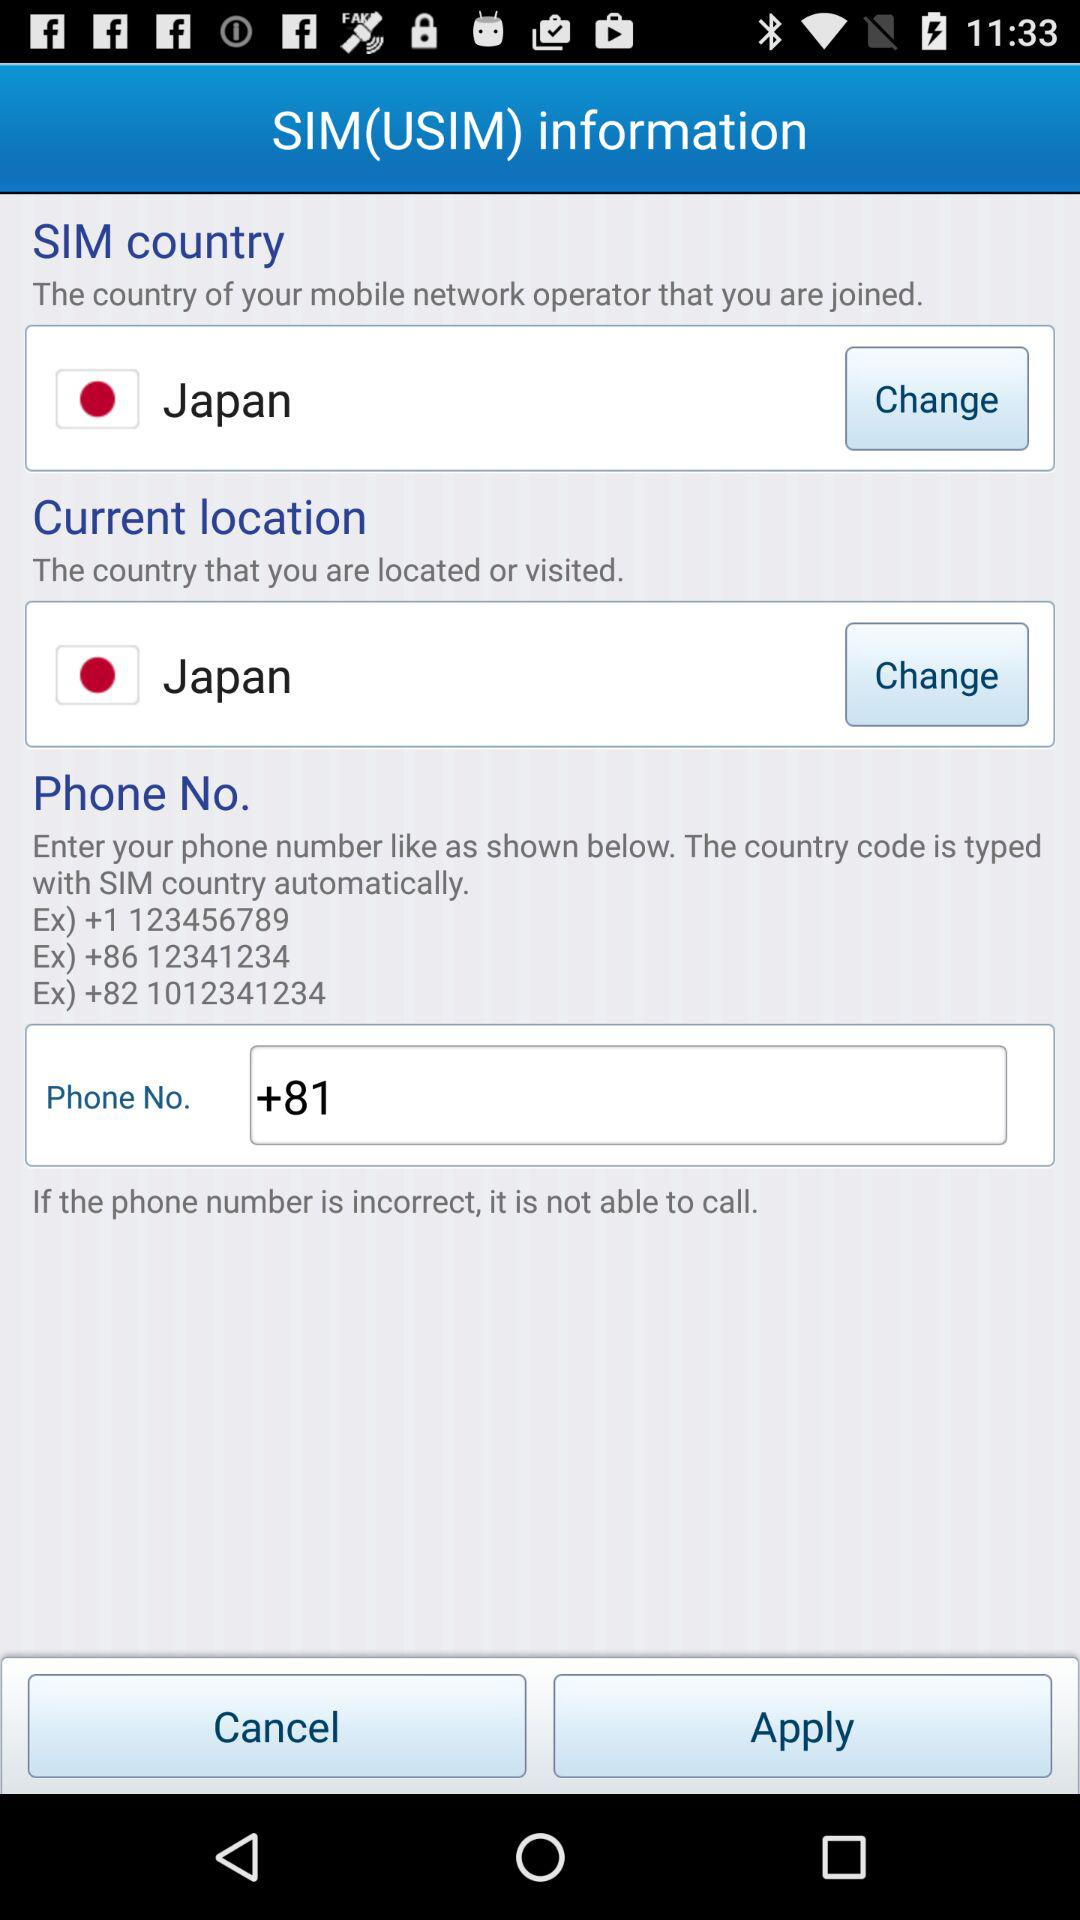What is the phone number starting with the country code +86? The phone number starting with the country code +86 is 12341234. 